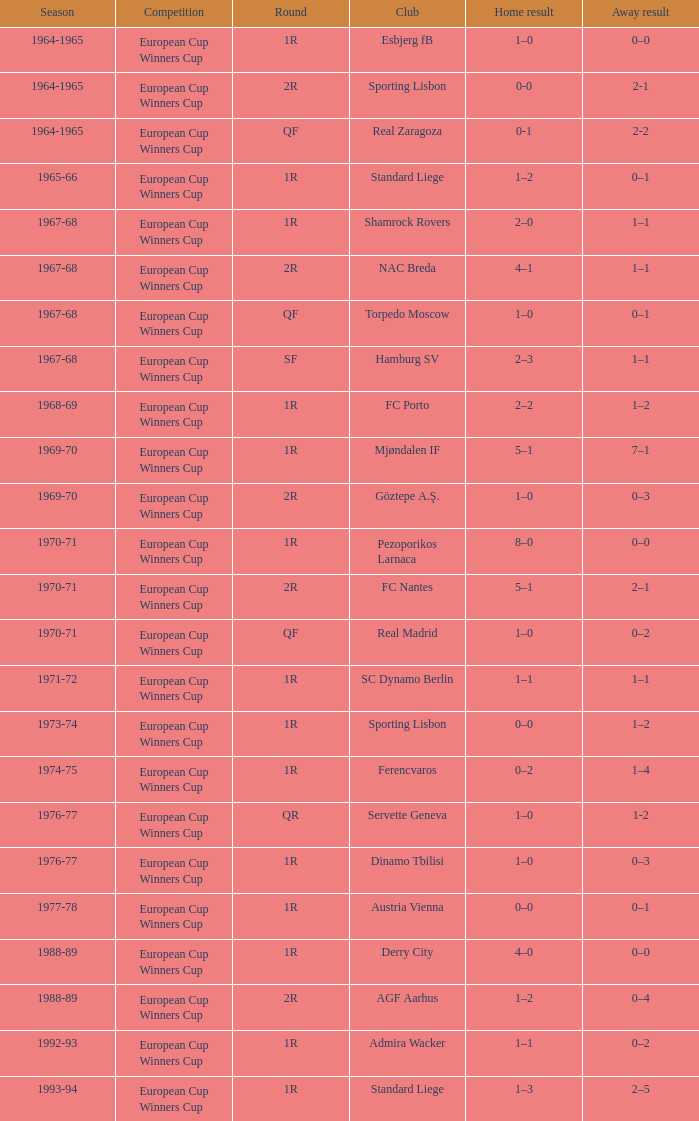Round of 2r, and a Home result of 0-0 has what season? 1964-1965. 